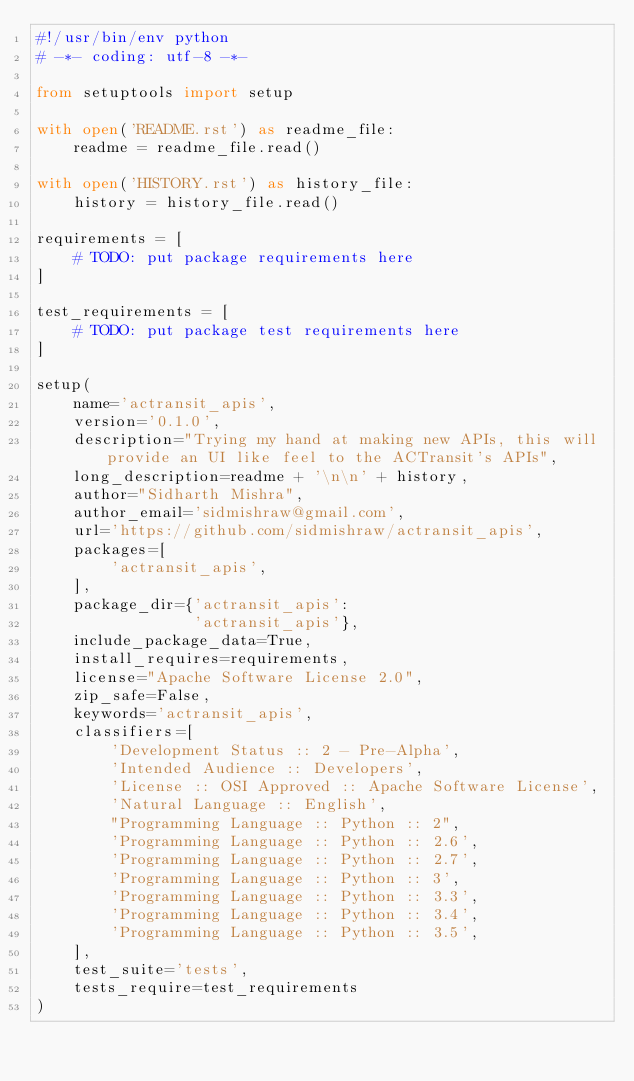<code> <loc_0><loc_0><loc_500><loc_500><_Python_>#!/usr/bin/env python
# -*- coding: utf-8 -*-

from setuptools import setup

with open('README.rst') as readme_file:
    readme = readme_file.read()

with open('HISTORY.rst') as history_file:
    history = history_file.read()

requirements = [
    # TODO: put package requirements here
]

test_requirements = [
    # TODO: put package test requirements here
]

setup(
    name='actransit_apis',
    version='0.1.0',
    description="Trying my hand at making new APIs, this will provide an UI like feel to the ACTransit's APIs",
    long_description=readme + '\n\n' + history,
    author="Sidharth Mishra",
    author_email='sidmishraw@gmail.com',
    url='https://github.com/sidmishraw/actransit_apis',
    packages=[
        'actransit_apis',
    ],
    package_dir={'actransit_apis':
                 'actransit_apis'},
    include_package_data=True,
    install_requires=requirements,
    license="Apache Software License 2.0",
    zip_safe=False,
    keywords='actransit_apis',
    classifiers=[
        'Development Status :: 2 - Pre-Alpha',
        'Intended Audience :: Developers',
        'License :: OSI Approved :: Apache Software License',
        'Natural Language :: English',
        "Programming Language :: Python :: 2",
        'Programming Language :: Python :: 2.6',
        'Programming Language :: Python :: 2.7',
        'Programming Language :: Python :: 3',
        'Programming Language :: Python :: 3.3',
        'Programming Language :: Python :: 3.4',
        'Programming Language :: Python :: 3.5',
    ],
    test_suite='tests',
    tests_require=test_requirements
)
</code> 